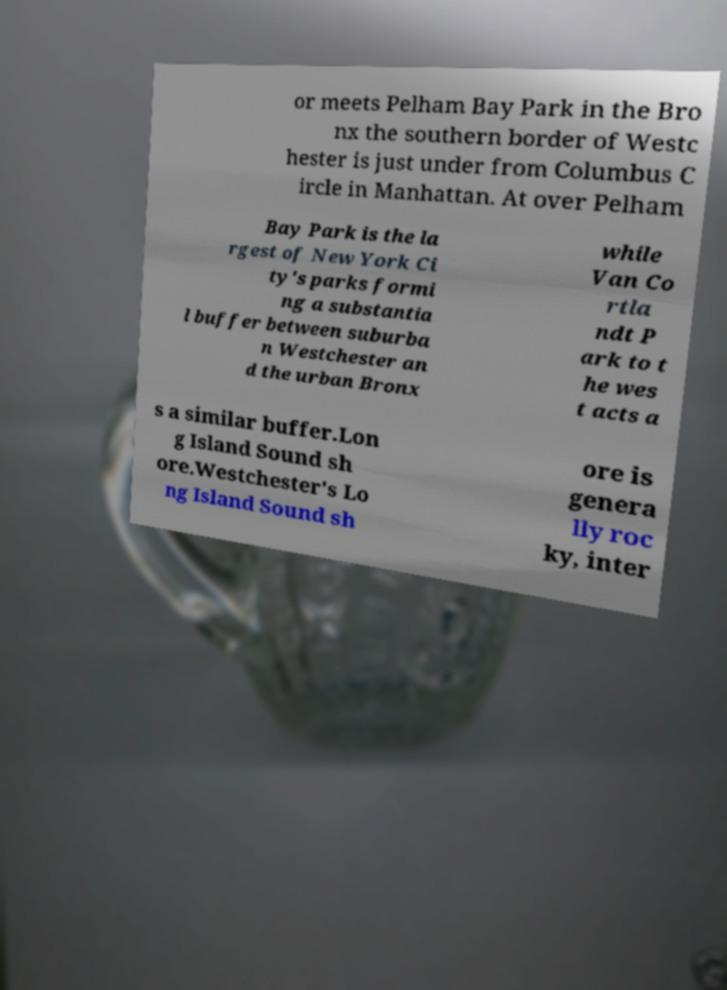What messages or text are displayed in this image? I need them in a readable, typed format. or meets Pelham Bay Park in the Bro nx the southern border of Westc hester is just under from Columbus C ircle in Manhattan. At over Pelham Bay Park is the la rgest of New York Ci ty's parks formi ng a substantia l buffer between suburba n Westchester an d the urban Bronx while Van Co rtla ndt P ark to t he wes t acts a s a similar buffer.Lon g Island Sound sh ore.Westchester's Lo ng Island Sound sh ore is genera lly roc ky, inter 